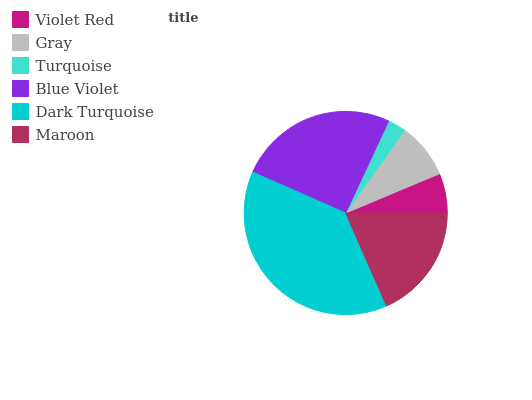Is Turquoise the minimum?
Answer yes or no. Yes. Is Dark Turquoise the maximum?
Answer yes or no. Yes. Is Gray the minimum?
Answer yes or no. No. Is Gray the maximum?
Answer yes or no. No. Is Gray greater than Violet Red?
Answer yes or no. Yes. Is Violet Red less than Gray?
Answer yes or no. Yes. Is Violet Red greater than Gray?
Answer yes or no. No. Is Gray less than Violet Red?
Answer yes or no. No. Is Maroon the high median?
Answer yes or no. Yes. Is Gray the low median?
Answer yes or no. Yes. Is Turquoise the high median?
Answer yes or no. No. Is Maroon the low median?
Answer yes or no. No. 